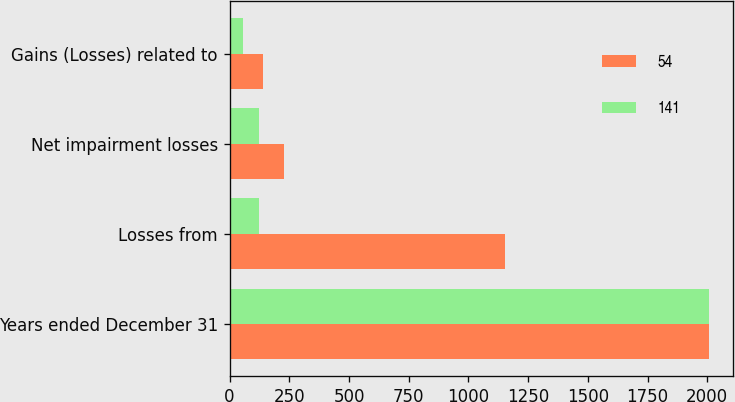<chart> <loc_0><loc_0><loc_500><loc_500><stacked_bar_chart><ecel><fcel>Years ended December 31<fcel>Losses from<fcel>Net impairment losses<fcel>Gains (Losses) related to<nl><fcel>54<fcel>2009<fcel>1155<fcel>227<fcel>141<nl><fcel>141<fcel>2008<fcel>122<fcel>122<fcel>54<nl></chart> 